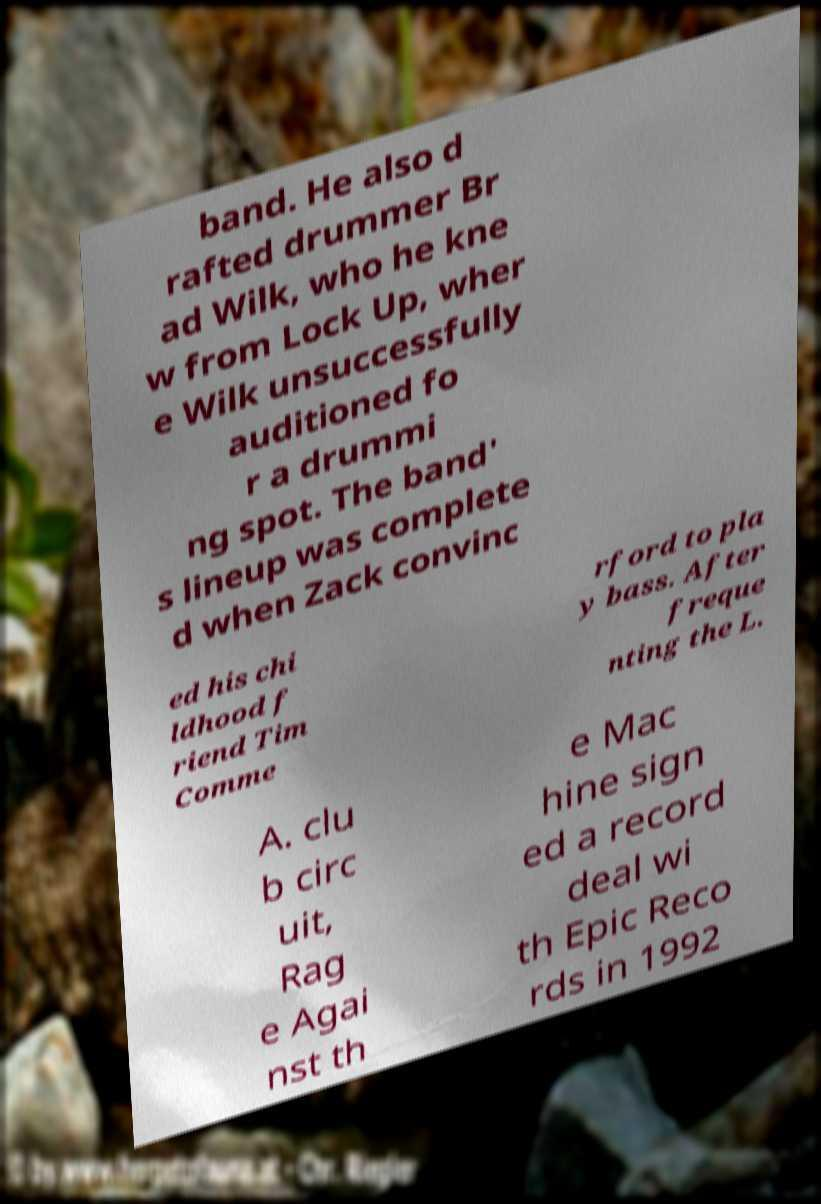Please identify and transcribe the text found in this image. band. He also d rafted drummer Br ad Wilk, who he kne w from Lock Up, wher e Wilk unsuccessfully auditioned fo r a drummi ng spot. The band' s lineup was complete d when Zack convinc ed his chi ldhood f riend Tim Comme rford to pla y bass. After freque nting the L. A. clu b circ uit, Rag e Agai nst th e Mac hine sign ed a record deal wi th Epic Reco rds in 1992 